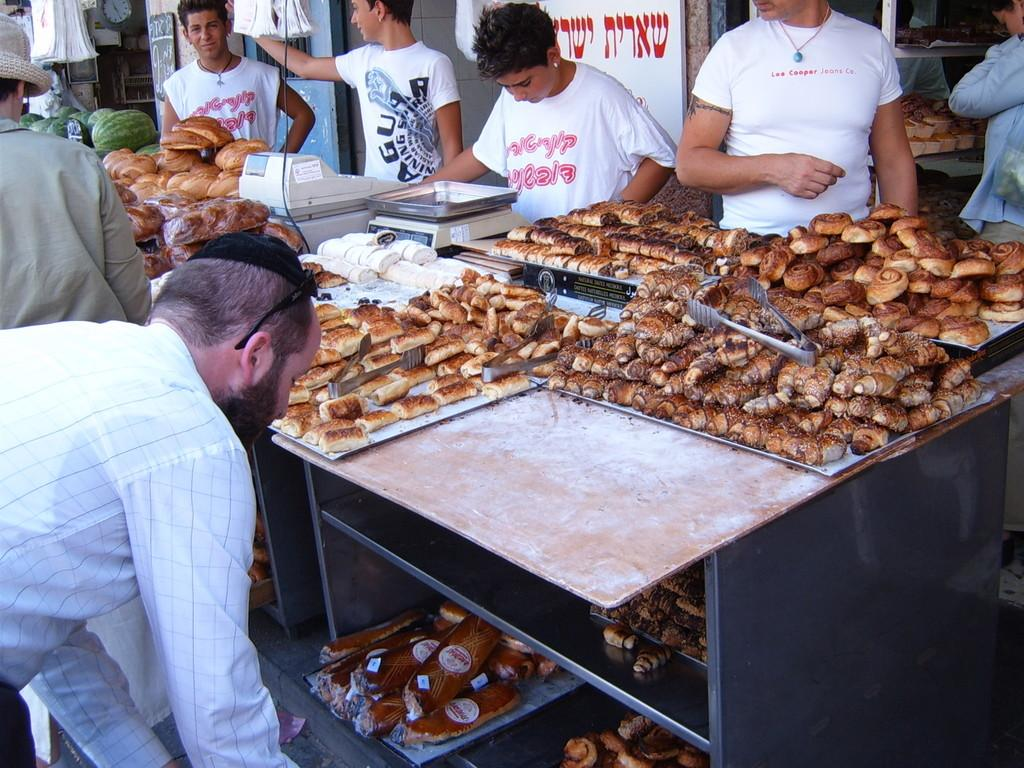How many people are in the image? There are people in the image, but the exact number is not specified. What object in the image is used for measuring weight? There is a weighing machine in the image. What type of food can be seen in the image? There is food in the image, including watermelons. What is used for storing or displaying items in the image? There are racks in the image. What type of bags are present in the image? There are bags in the image, but their specific type is not mentioned. What is the purpose of the board in the image? The purpose of the board in the image is not specified. Where is the clock located in the image? The clock is on the wall in the image. How many buttons are on the watermelons in the image? There are no buttons on the watermelons in the image, as watermelons are a type of fruit and do not have buttons. 